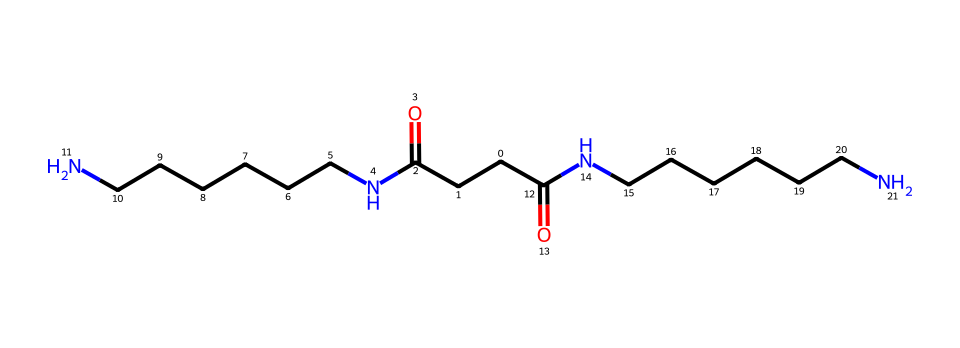What is the number of carbon atoms in the chemical structure? By examining the SMILES representation, count the letter "C" which denotes carbon atoms. The overall carbon count in the structure gives us the total number.
Answer: six How many nitrogen atoms are present in the compound? In the SMILES representation, count the instances of the letter "N", which signifies nitrogen atoms in the structure. Each occurrence contributes to the total number.
Answer: four What type of functional group is indicated in this chemical structure? Analyzing the SMILES, we can identify the presence of C(=O) groups, which indicate amide functional groups. The presence of "N" (nitrogens) linked to carbonyls denotes the specific functionality.
Answer: amide Is this fiber likely to be hydrophilic or hydrophobic? The presence of nitrogen and carbonyl groups in the structure suggests interactions with water, therefore indicating a stronger hydrophilic characteristic rather than hydrophobic.
Answer: hydrophilic What physical property does the presence of multiple nitrogen atoms suggest about this fiber? The multiple nitrogen atoms indicate a degree of polarity and can suggest higher strength and resilience in fibers, especially impacting tensile strength.
Answer: stronger 